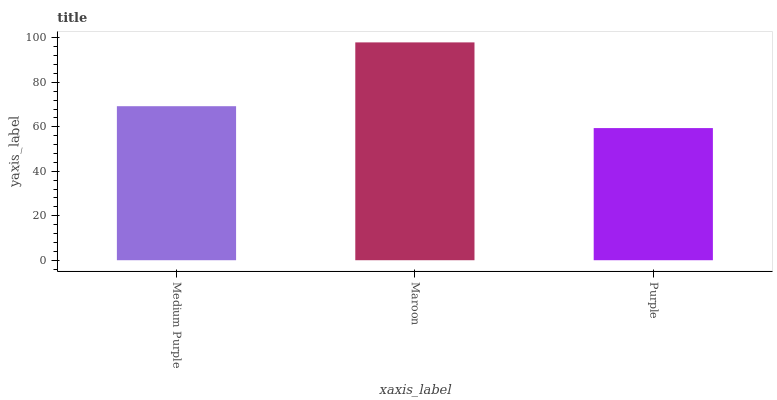Is Purple the minimum?
Answer yes or no. Yes. Is Maroon the maximum?
Answer yes or no. Yes. Is Maroon the minimum?
Answer yes or no. No. Is Purple the maximum?
Answer yes or no. No. Is Maroon greater than Purple?
Answer yes or no. Yes. Is Purple less than Maroon?
Answer yes or no. Yes. Is Purple greater than Maroon?
Answer yes or no. No. Is Maroon less than Purple?
Answer yes or no. No. Is Medium Purple the high median?
Answer yes or no. Yes. Is Medium Purple the low median?
Answer yes or no. Yes. Is Purple the high median?
Answer yes or no. No. Is Purple the low median?
Answer yes or no. No. 